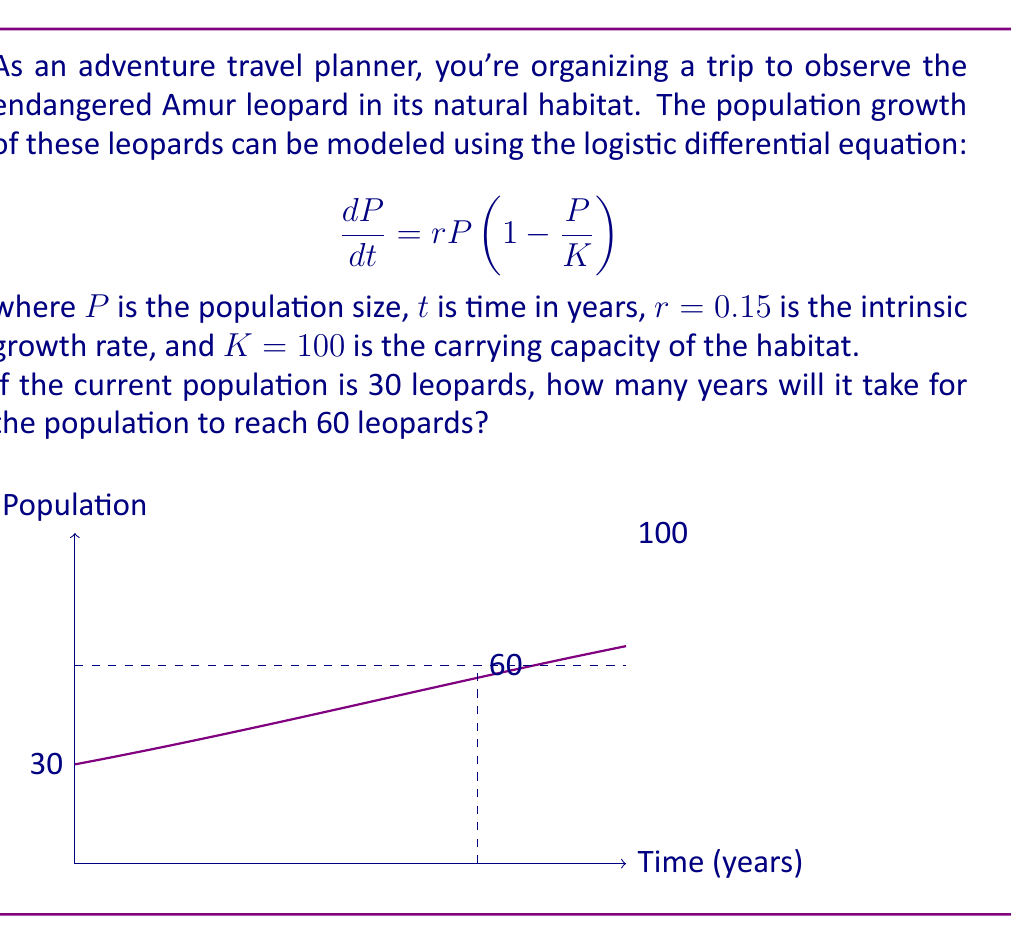Can you answer this question? To solve this problem, we need to use the logistic growth model and integrate it to find the time required for the population to double.

1) The logistic differential equation is:

   $$\frac{dP}{dt} = rP(1 - \frac{P}{K})$$

2) Separating variables and integrating:

   $$\int_{P_0}^P \frac{dP}{P(1-P/K)} = \int_0^t r dt$$

3) Solving the integral (omitting steps):

   $$\ln(\frac{P}{K-P}) - \ln(\frac{P_0}{K-P_0}) = rt$$

4) Substituting the known values ($P_0 = 30$, $P = 60$, $K = 100$, $r = 0.15$):

   $$\ln(\frac{60}{40}) - \ln(\frac{30}{70}) = 0.15t$$

5) Simplifying:

   $$\ln(1.5) - \ln(\frac{3}{7}) = 0.15t$$

6) Solving for $t$:

   $$t = \frac{\ln(1.5) - \ln(\frac{3}{7})}{0.15} \approx 21.9$$

Therefore, it will take approximately 21.9 years for the Amur leopard population to grow from 30 to 60 individuals.
Answer: 21.9 years 